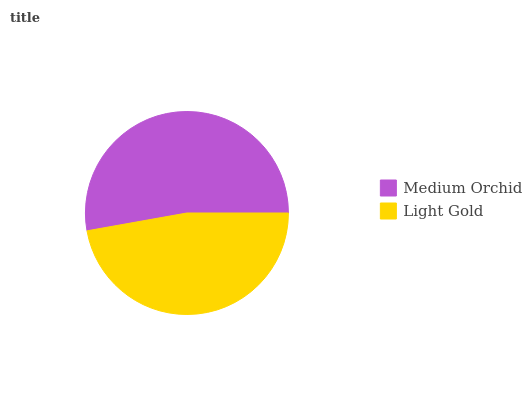Is Light Gold the minimum?
Answer yes or no. Yes. Is Medium Orchid the maximum?
Answer yes or no. Yes. Is Light Gold the maximum?
Answer yes or no. No. Is Medium Orchid greater than Light Gold?
Answer yes or no. Yes. Is Light Gold less than Medium Orchid?
Answer yes or no. Yes. Is Light Gold greater than Medium Orchid?
Answer yes or no. No. Is Medium Orchid less than Light Gold?
Answer yes or no. No. Is Medium Orchid the high median?
Answer yes or no. Yes. Is Light Gold the low median?
Answer yes or no. Yes. Is Light Gold the high median?
Answer yes or no. No. Is Medium Orchid the low median?
Answer yes or no. No. 